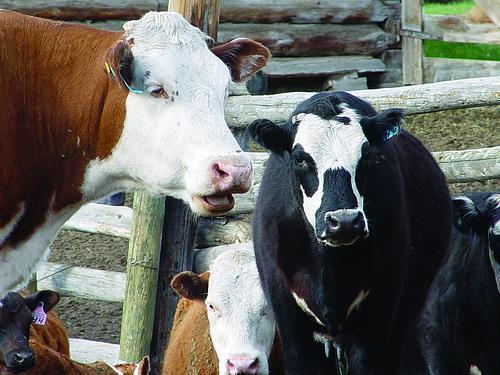How many cows are clearly brown and white in this photo?
Give a very brief answer. 2. How many cows have a mouth visibly open in this photo?
Give a very brief answer. 1. 